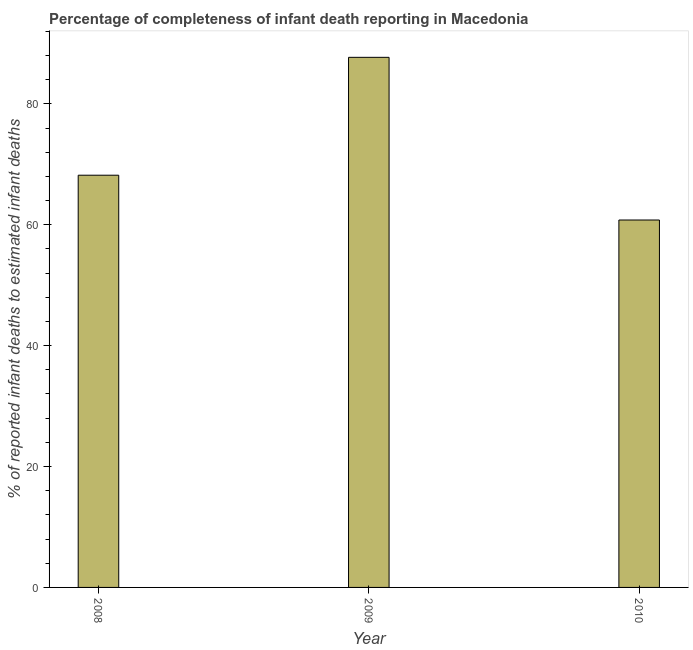Does the graph contain grids?
Give a very brief answer. No. What is the title of the graph?
Ensure brevity in your answer.  Percentage of completeness of infant death reporting in Macedonia. What is the label or title of the Y-axis?
Offer a very short reply. % of reported infant deaths to estimated infant deaths. What is the completeness of infant death reporting in 2008?
Your answer should be compact. 68.2. Across all years, what is the maximum completeness of infant death reporting?
Offer a very short reply. 87.7. Across all years, what is the minimum completeness of infant death reporting?
Provide a short and direct response. 60.78. In which year was the completeness of infant death reporting maximum?
Provide a succinct answer. 2009. What is the sum of the completeness of infant death reporting?
Make the answer very short. 216.68. What is the difference between the completeness of infant death reporting in 2008 and 2010?
Make the answer very short. 7.41. What is the average completeness of infant death reporting per year?
Ensure brevity in your answer.  72.23. What is the median completeness of infant death reporting?
Your answer should be compact. 68.2. In how many years, is the completeness of infant death reporting greater than 28 %?
Your answer should be very brief. 3. What is the ratio of the completeness of infant death reporting in 2008 to that in 2009?
Your answer should be very brief. 0.78. Is the completeness of infant death reporting in 2008 less than that in 2010?
Your answer should be very brief. No. What is the difference between the highest and the second highest completeness of infant death reporting?
Your answer should be very brief. 19.5. What is the difference between the highest and the lowest completeness of infant death reporting?
Keep it short and to the point. 26.91. How many bars are there?
Ensure brevity in your answer.  3. How many years are there in the graph?
Offer a terse response. 3. What is the difference between two consecutive major ticks on the Y-axis?
Provide a short and direct response. 20. What is the % of reported infant deaths to estimated infant deaths in 2008?
Keep it short and to the point. 68.2. What is the % of reported infant deaths to estimated infant deaths in 2009?
Provide a short and direct response. 87.7. What is the % of reported infant deaths to estimated infant deaths in 2010?
Your response must be concise. 60.78. What is the difference between the % of reported infant deaths to estimated infant deaths in 2008 and 2009?
Your response must be concise. -19.5. What is the difference between the % of reported infant deaths to estimated infant deaths in 2008 and 2010?
Keep it short and to the point. 7.41. What is the difference between the % of reported infant deaths to estimated infant deaths in 2009 and 2010?
Your answer should be very brief. 26.91. What is the ratio of the % of reported infant deaths to estimated infant deaths in 2008 to that in 2009?
Offer a very short reply. 0.78. What is the ratio of the % of reported infant deaths to estimated infant deaths in 2008 to that in 2010?
Provide a succinct answer. 1.12. What is the ratio of the % of reported infant deaths to estimated infant deaths in 2009 to that in 2010?
Your response must be concise. 1.44. 